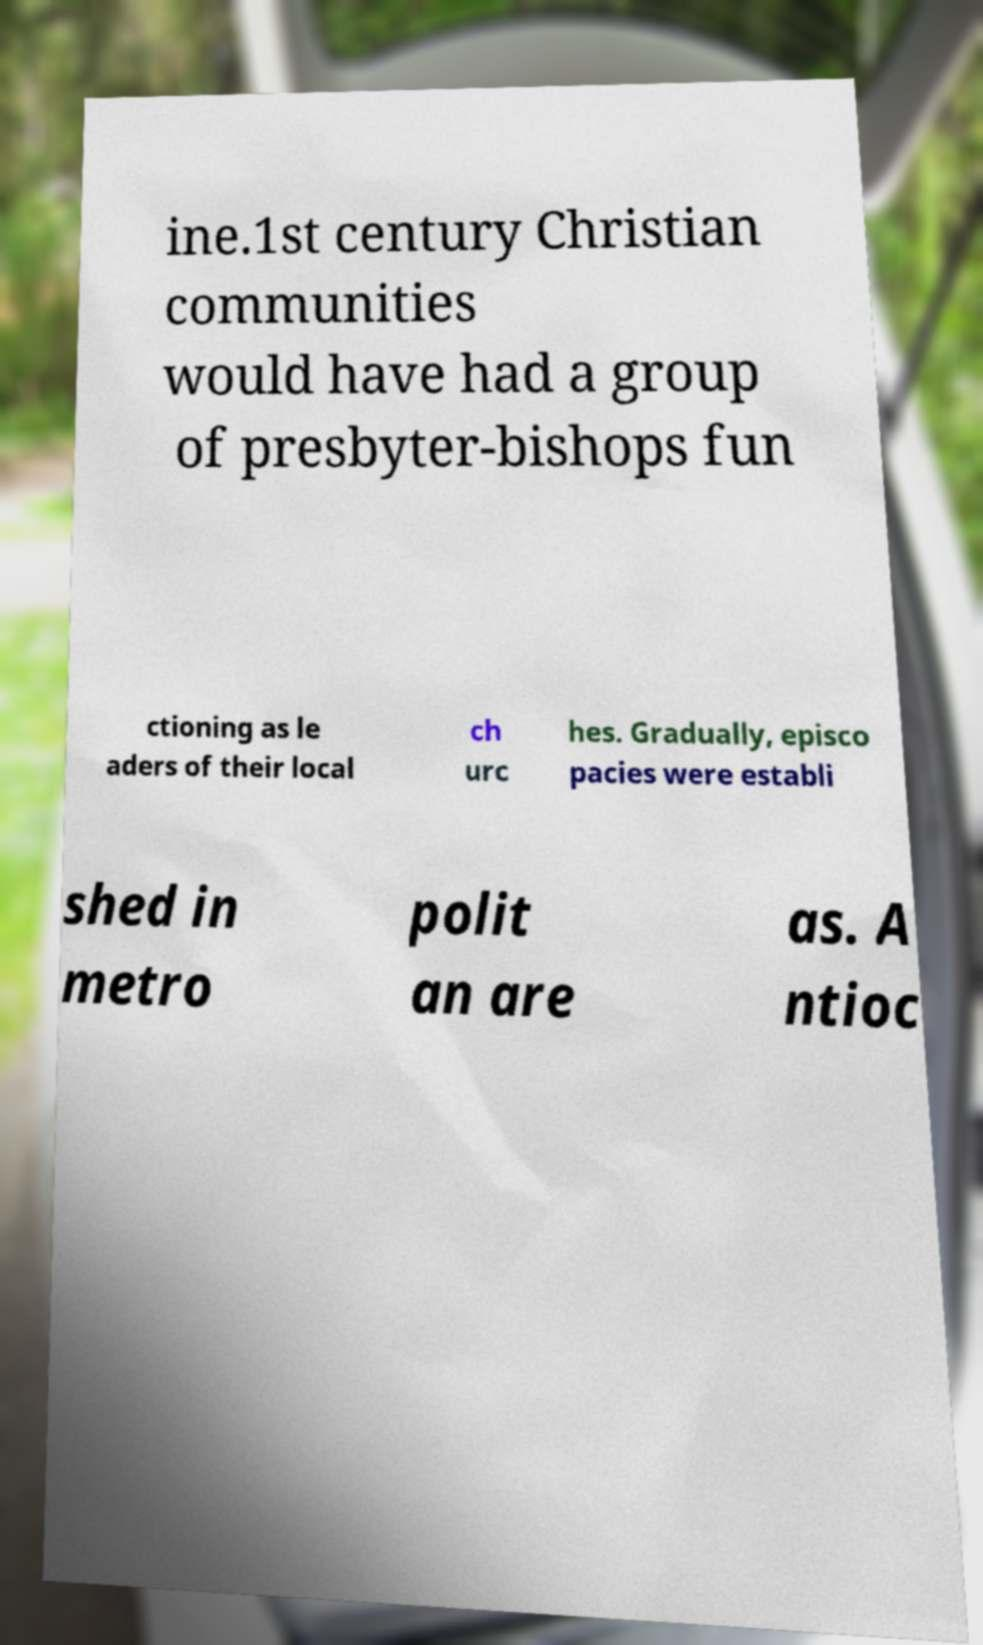Please identify and transcribe the text found in this image. ine.1st century Christian communities would have had a group of presbyter-bishops fun ctioning as le aders of their local ch urc hes. Gradually, episco pacies were establi shed in metro polit an are as. A ntioc 